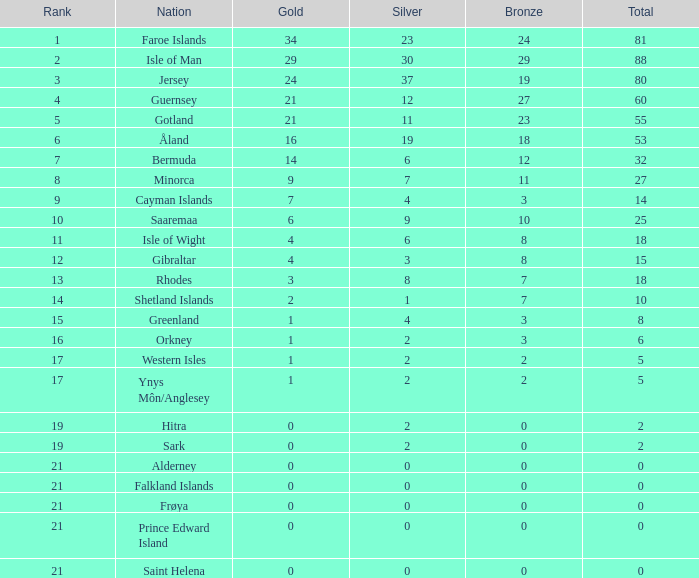What is the total number of silver medals earned by individuals with over 3 bronze and precisely 16 gold? 19.0. 